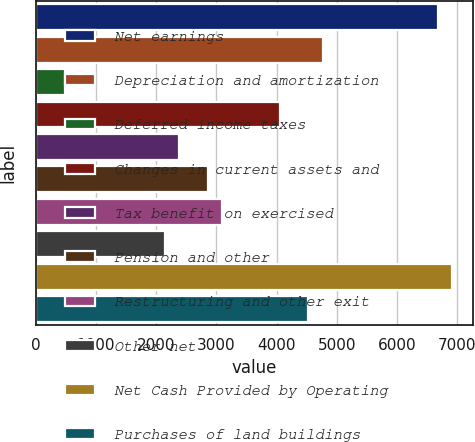Convert chart to OTSL. <chart><loc_0><loc_0><loc_500><loc_500><bar_chart><fcel>Net earnings<fcel>Depreciation and amortization<fcel>Deferred income taxes<fcel>Changes in current assets and<fcel>Tax benefit on exercised<fcel>Pension and other<fcel>Restructuring and other exit<fcel>Other net<fcel>Net Cash Provided by Operating<fcel>Purchases of land buildings<nl><fcel>6676.2<fcel>4769<fcel>477.8<fcel>4053.8<fcel>2385<fcel>2861.8<fcel>3100.2<fcel>2146.6<fcel>6914.6<fcel>4530.6<nl></chart> 